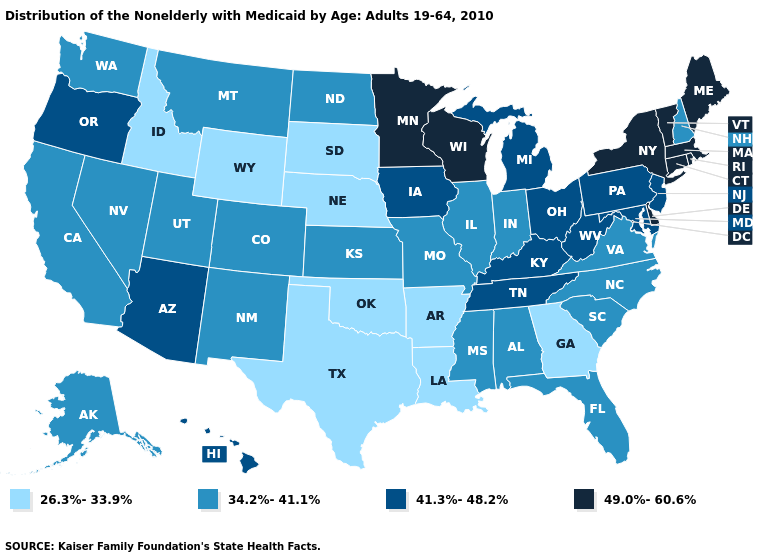Name the states that have a value in the range 26.3%-33.9%?
Write a very short answer. Arkansas, Georgia, Idaho, Louisiana, Nebraska, Oklahoma, South Dakota, Texas, Wyoming. Which states have the highest value in the USA?
Quick response, please. Connecticut, Delaware, Maine, Massachusetts, Minnesota, New York, Rhode Island, Vermont, Wisconsin. Name the states that have a value in the range 41.3%-48.2%?
Short answer required. Arizona, Hawaii, Iowa, Kentucky, Maryland, Michigan, New Jersey, Ohio, Oregon, Pennsylvania, Tennessee, West Virginia. Which states hav the highest value in the MidWest?
Write a very short answer. Minnesota, Wisconsin. Name the states that have a value in the range 26.3%-33.9%?
Short answer required. Arkansas, Georgia, Idaho, Louisiana, Nebraska, Oklahoma, South Dakota, Texas, Wyoming. Does Maine have the lowest value in the Northeast?
Keep it brief. No. What is the highest value in the Northeast ?
Concise answer only. 49.0%-60.6%. Name the states that have a value in the range 49.0%-60.6%?
Keep it brief. Connecticut, Delaware, Maine, Massachusetts, Minnesota, New York, Rhode Island, Vermont, Wisconsin. Does New Hampshire have the lowest value in the Northeast?
Keep it brief. Yes. What is the value of Maryland?
Short answer required. 41.3%-48.2%. Name the states that have a value in the range 41.3%-48.2%?
Write a very short answer. Arizona, Hawaii, Iowa, Kentucky, Maryland, Michigan, New Jersey, Ohio, Oregon, Pennsylvania, Tennessee, West Virginia. Does Maine have the highest value in the USA?
Short answer required. Yes. What is the value of Alabama?
Short answer required. 34.2%-41.1%. What is the highest value in the Northeast ?
Answer briefly. 49.0%-60.6%. What is the value of Washington?
Short answer required. 34.2%-41.1%. 